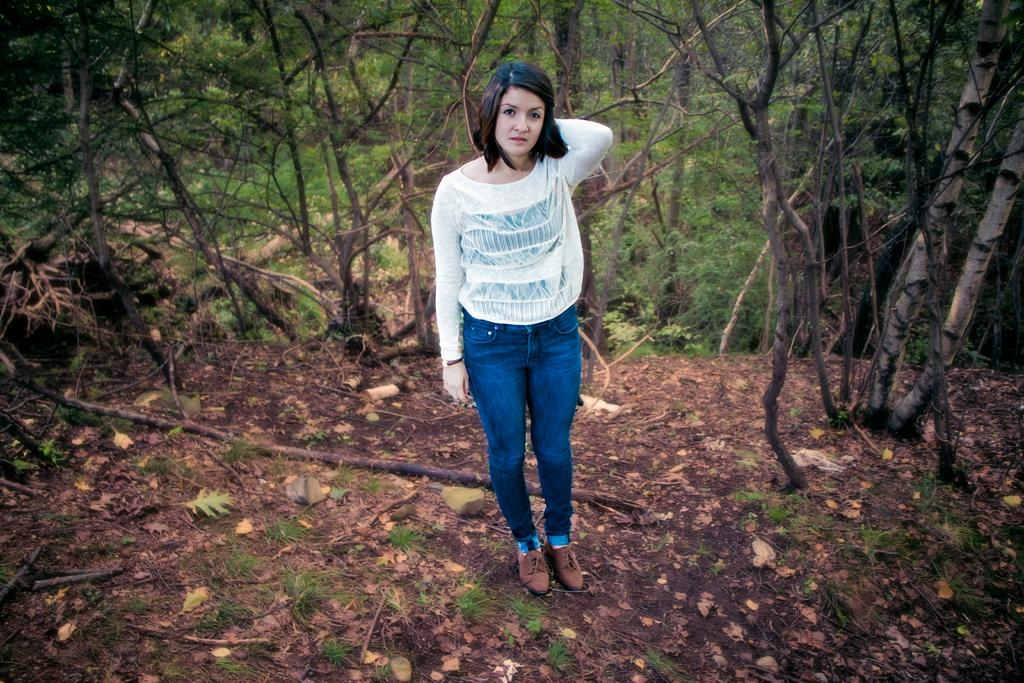Who is the main subject in the image? There is a woman in the image. What is the woman's position in relation to the ground? The woman is standing on the ground. What can be seen in the background of the image? There are trees in the background of the image. What account does the woman have to make a decision about in the image? There is no account or decision-making process mentioned or depicted in the image. 